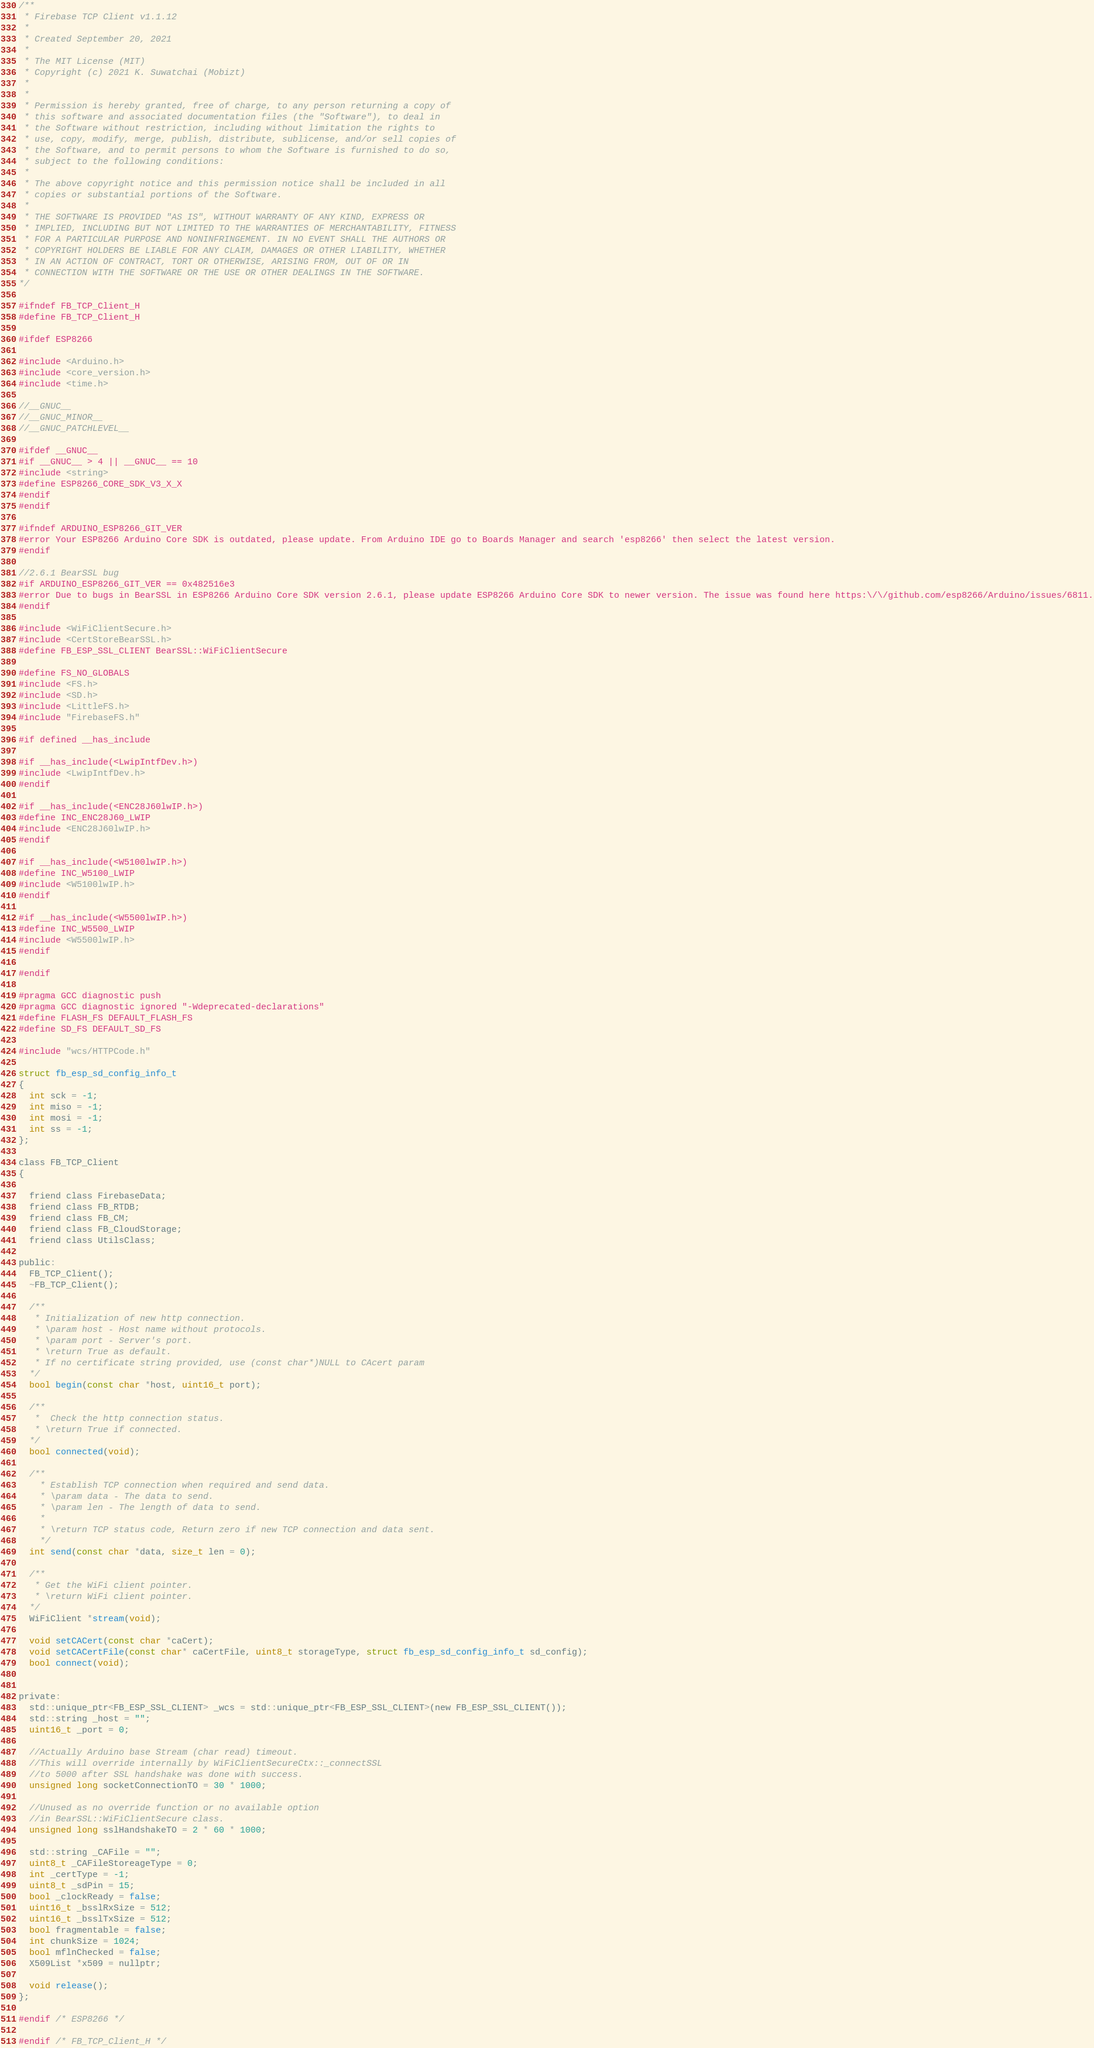Convert code to text. <code><loc_0><loc_0><loc_500><loc_500><_C_>/**
 * Firebase TCP Client v1.1.12
 * 
 * Created September 20, 2021
 * 
 * The MIT License (MIT)
 * Copyright (c) 2021 K. Suwatchai (Mobizt)
 * 
 * 
 * Permission is hereby granted, free of charge, to any person returning a copy of
 * this software and associated documentation files (the "Software"), to deal in
 * the Software without restriction, including without limitation the rights to
 * use, copy, modify, merge, publish, distribute, sublicense, and/or sell copies of
 * the Software, and to permit persons to whom the Software is furnished to do so,
 * subject to the following conditions:
 * 
 * The above copyright notice and this permission notice shall be included in all
 * copies or substantial portions of the Software.
 * 
 * THE SOFTWARE IS PROVIDED "AS IS", WITHOUT WARRANTY OF ANY KIND, EXPRESS OR
 * IMPLIED, INCLUDING BUT NOT LIMITED TO THE WARRANTIES OF MERCHANTABILITY, FITNESS
 * FOR A PARTICULAR PURPOSE AND NONINFRINGEMENT. IN NO EVENT SHALL THE AUTHORS OR
 * COPYRIGHT HOLDERS BE LIABLE FOR ANY CLAIM, DAMAGES OR OTHER LIABILITY, WHETHER
 * IN AN ACTION OF CONTRACT, TORT OR OTHERWISE, ARISING FROM, OUT OF OR IN
 * CONNECTION WITH THE SOFTWARE OR THE USE OR OTHER DEALINGS IN THE SOFTWARE.
*/

#ifndef FB_TCP_Client_H
#define FB_TCP_Client_H

#ifdef ESP8266

#include <Arduino.h>
#include <core_version.h>
#include <time.h>

//__GNUC__
//__GNUC_MINOR__
//__GNUC_PATCHLEVEL__

#ifdef __GNUC__
#if __GNUC__ > 4 || __GNUC__ == 10
#include <string>
#define ESP8266_CORE_SDK_V3_X_X
#endif
#endif

#ifndef ARDUINO_ESP8266_GIT_VER
#error Your ESP8266 Arduino Core SDK is outdated, please update. From Arduino IDE go to Boards Manager and search 'esp8266' then select the latest version.
#endif

//2.6.1 BearSSL bug
#if ARDUINO_ESP8266_GIT_VER == 0x482516e3
#error Due to bugs in BearSSL in ESP8266 Arduino Core SDK version 2.6.1, please update ESP8266 Arduino Core SDK to newer version. The issue was found here https:\/\/github.com/esp8266/Arduino/issues/6811.
#endif

#include <WiFiClientSecure.h>
#include <CertStoreBearSSL.h>
#define FB_ESP_SSL_CLIENT BearSSL::WiFiClientSecure

#define FS_NO_GLOBALS
#include <FS.h>
#include <SD.h>
#include <LittleFS.h>
#include "FirebaseFS.h"

#if defined __has_include

#if __has_include(<LwipIntfDev.h>)
#include <LwipIntfDev.h>
#endif

#if __has_include(<ENC28J60lwIP.h>)
#define INC_ENC28J60_LWIP
#include <ENC28J60lwIP.h>
#endif

#if __has_include(<W5100lwIP.h>)
#define INC_W5100_LWIP
#include <W5100lwIP.h>
#endif

#if __has_include(<W5500lwIP.h>)
#define INC_W5500_LWIP
#include <W5500lwIP.h>
#endif

#endif

#pragma GCC diagnostic push
#pragma GCC diagnostic ignored "-Wdeprecated-declarations"
#define FLASH_FS DEFAULT_FLASH_FS
#define SD_FS DEFAULT_SD_FS

#include "wcs/HTTPCode.h"

struct fb_esp_sd_config_info_t
{
  int sck = -1;
  int miso = -1;
  int mosi = -1;
  int ss = -1;
};

class FB_TCP_Client
{

  friend class FirebaseData;
  friend class FB_RTDB;
  friend class FB_CM;
  friend class FB_CloudStorage;
  friend class UtilsClass;

public:
  FB_TCP_Client();
  ~FB_TCP_Client();

  /**
   * Initialization of new http connection.
   * \param host - Host name without protocols.
   * \param port - Server's port.
   * \return True as default.
   * If no certificate string provided, use (const char*)NULL to CAcert param 
  */
  bool begin(const char *host, uint16_t port);

  /**
   *  Check the http connection status.
   * \return True if connected.
  */
  bool connected(void);

  /**
    * Establish TCP connection when required and send data.
    * \param data - The data to send.
    * \param len - The length of data to send.
    * 
    * \return TCP status code, Return zero if new TCP connection and data sent.
    */
  int send(const char *data, size_t len = 0);

  /**
   * Get the WiFi client pointer.
   * \return WiFi client pointer.
  */
  WiFiClient *stream(void);

  void setCACert(const char *caCert);
  void setCACertFile(const char* caCertFile, uint8_t storageType, struct fb_esp_sd_config_info_t sd_config);
  bool connect(void);


private:
  std::unique_ptr<FB_ESP_SSL_CLIENT> _wcs = std::unique_ptr<FB_ESP_SSL_CLIENT>(new FB_ESP_SSL_CLIENT());
  std::string _host = "";
  uint16_t _port = 0;

  //Actually Arduino base Stream (char read) timeout.
  //This will override internally by WiFiClientSecureCtx::_connectSSL 
  //to 5000 after SSL handshake was done with success.
  unsigned long socketConnectionTO = 30 * 1000;

  //Unused as no override function or no available option 
  //in BearSSL::WiFiClientSecure class.
  unsigned long sslHandshakeTO = 2 * 60 * 1000;

  std::string _CAFile = "";
  uint8_t _CAFileStoreageType = 0;
  int _certType = -1;
  uint8_t _sdPin = 15;
  bool _clockReady = false;
  uint16_t _bsslRxSize = 512;
  uint16_t _bsslTxSize = 512;
  bool fragmentable = false;
  int chunkSize = 1024;
  bool mflnChecked = false;
  X509List *x509 = nullptr;

  void release();
};

#endif /* ESP8266 */

#endif /* FB_TCP_Client_H */</code> 